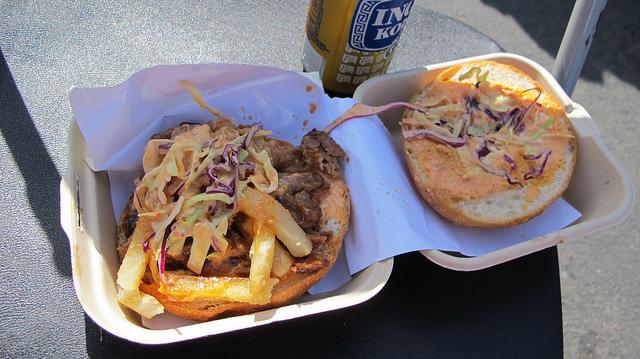Would the two food objects ever by stacked on top of each other?
Keep it brief. Yes. Is this junk food?
Give a very brief answer. Yes. What genre of food is this?
Answer briefly. American. 